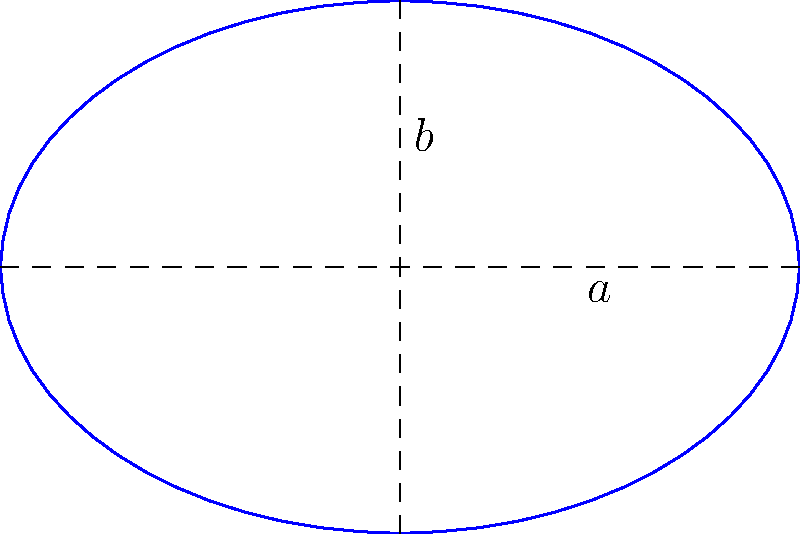You're designing an oval-shaped accessory for a wooden doll. The accessory can be represented by an ellipse with a semi-major axis (a) of 3 cm and a semi-minor axis (b) of 2 cm. Calculate the area of this elliptical accessory. To calculate the area of an ellipse, we use the formula:

$$A = \pi ab$$

Where:
$A$ is the area of the ellipse
$\pi$ is approximately 3.14159
$a$ is the length of the semi-major axis
$b$ is the length of the semi-minor axis

Given:
$a = 3$ cm
$b = 2$ cm

Let's substitute these values into the formula:

$$A = \pi \cdot 3 \cdot 2$$

$$A = 6\pi$$

To get a numerical value, we can multiply by $\pi$:

$$A \approx 6 \cdot 3.14159$$

$$A \approx 18.85 \text{ cm}^2$$

Therefore, the area of the elliptical accessory is approximately 18.85 square centimeters.
Answer: $6\pi$ cm² or approximately 18.85 cm² 